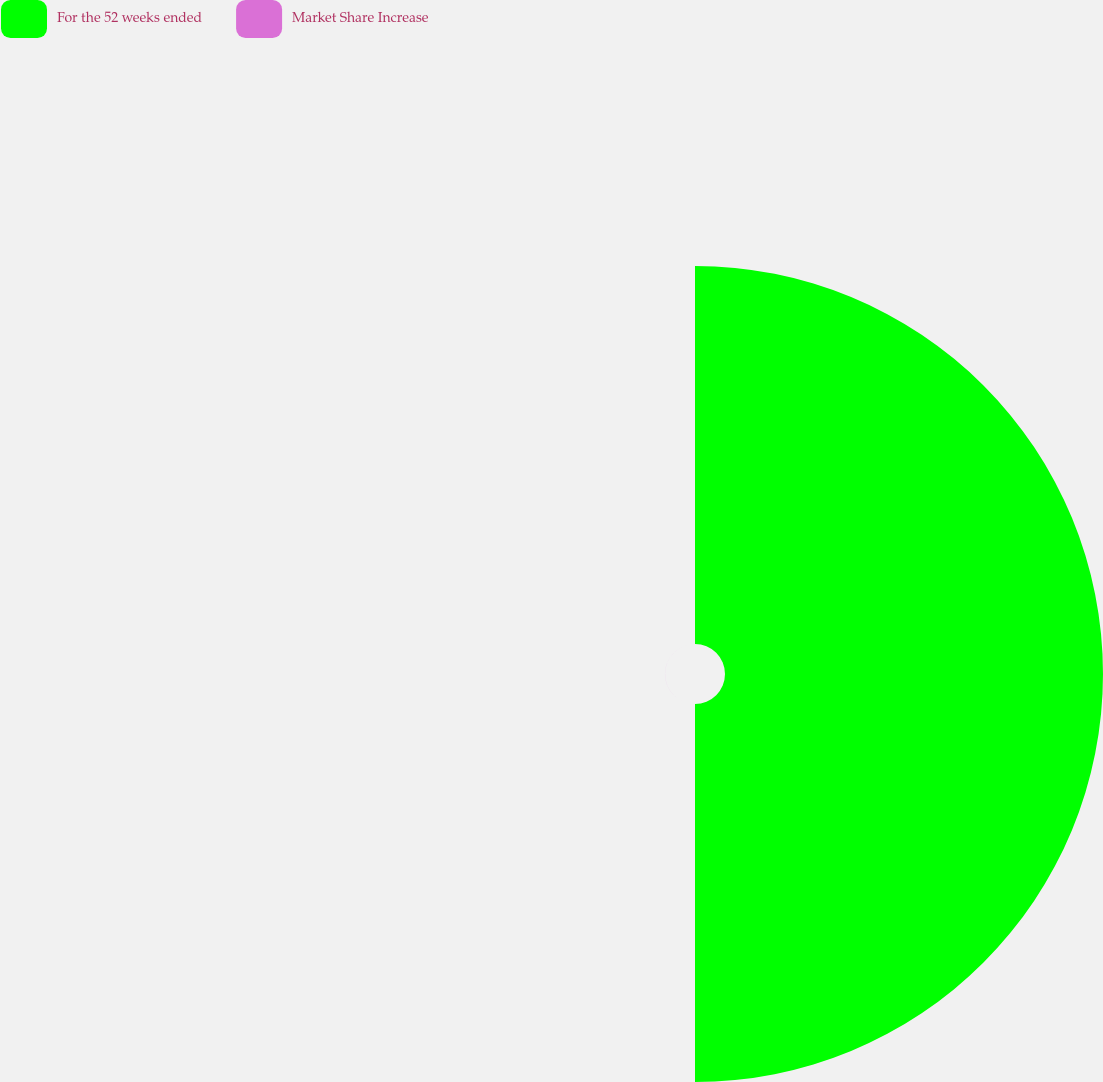<chart> <loc_0><loc_0><loc_500><loc_500><pie_chart><fcel>For the 52 weeks ended<fcel>Market Share Increase<nl><fcel>99.99%<fcel>0.01%<nl></chart> 